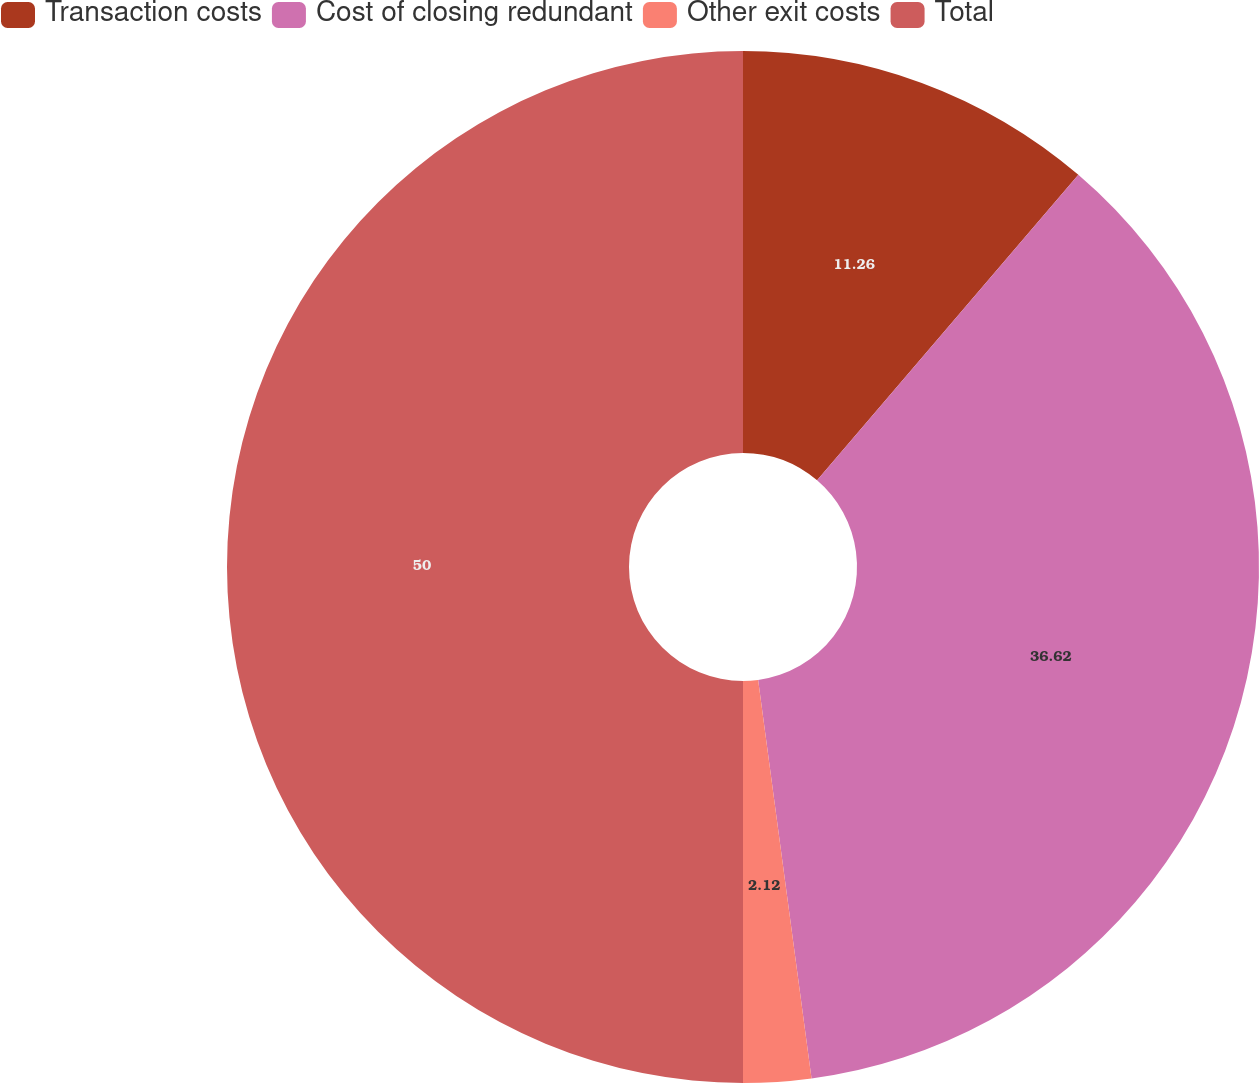Convert chart to OTSL. <chart><loc_0><loc_0><loc_500><loc_500><pie_chart><fcel>Transaction costs<fcel>Cost of closing redundant<fcel>Other exit costs<fcel>Total<nl><fcel>11.26%<fcel>36.62%<fcel>2.12%<fcel>50.0%<nl></chart> 